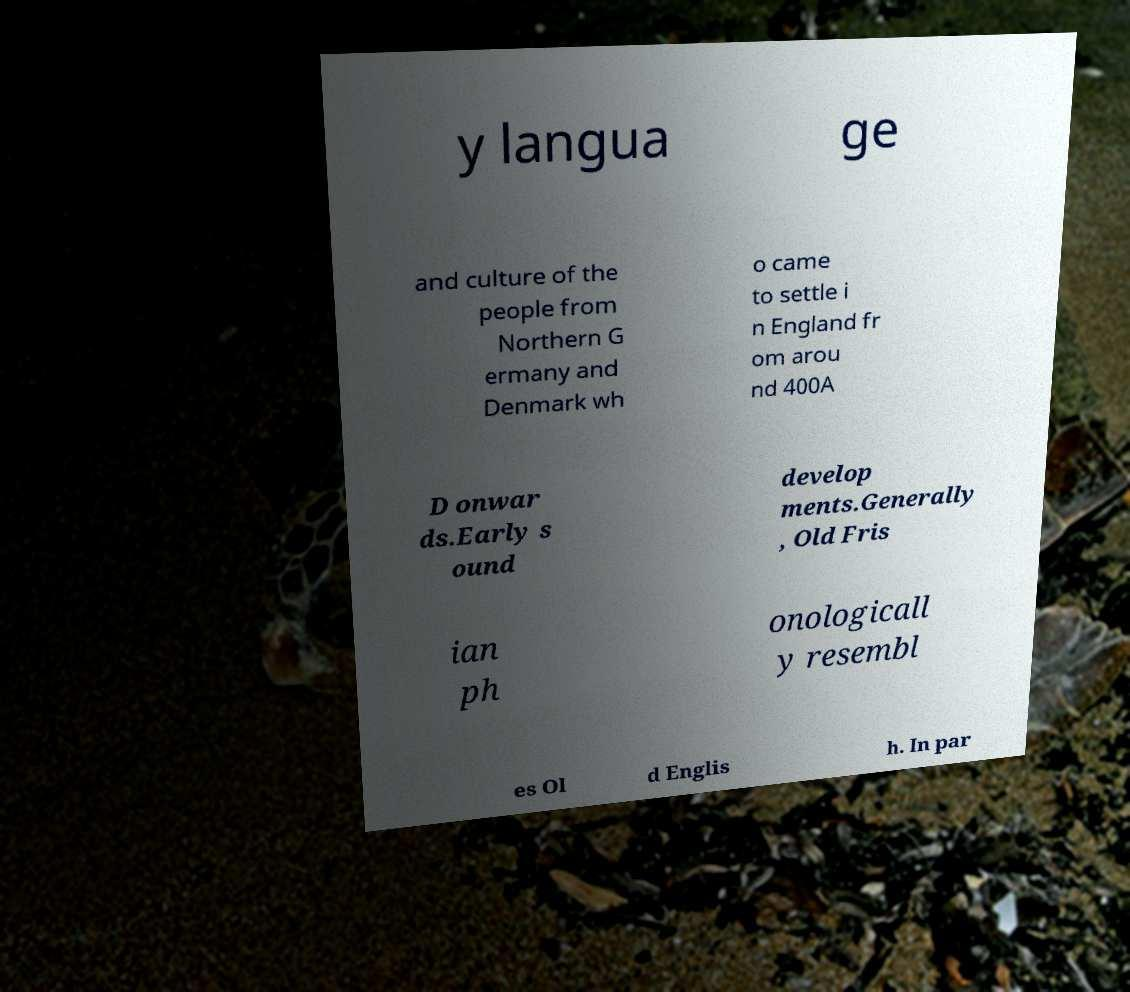Please identify and transcribe the text found in this image. y langua ge and culture of the people from Northern G ermany and Denmark wh o came to settle i n England fr om arou nd 400A D onwar ds.Early s ound develop ments.Generally , Old Fris ian ph onologicall y resembl es Ol d Englis h. In par 